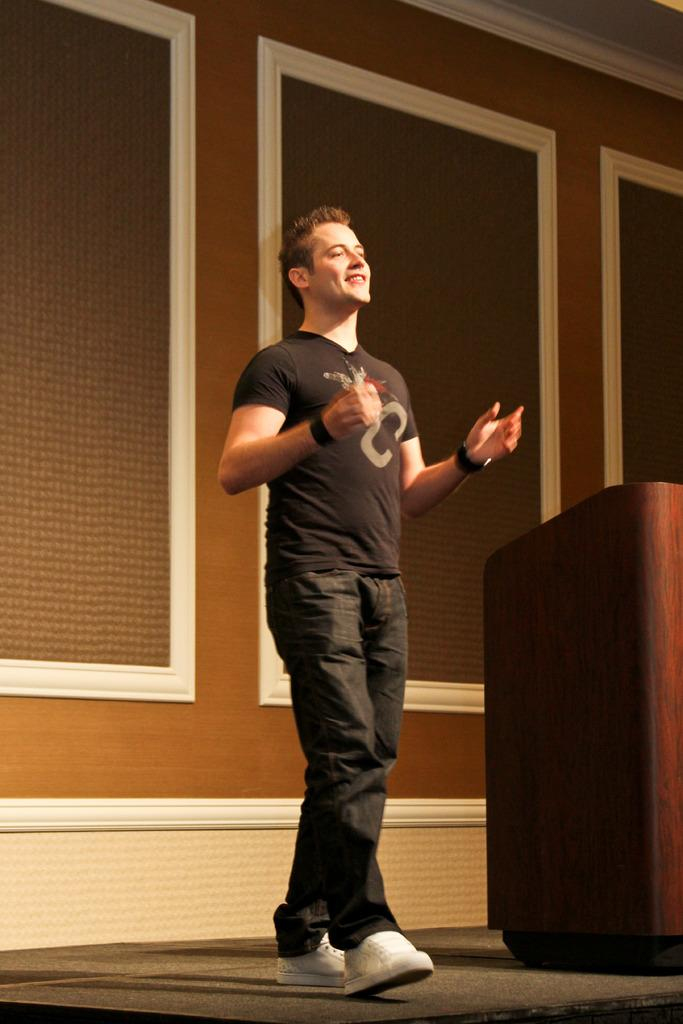Who is present in the image? There is a man in the image. What is the man doing in the image? The man is walking and smiling. What object can be seen in the image that is typically used for speeches or presentations? There is a podium in the image. What is visible in the background of the image? There is a wall in the background of the image. What type of ring can be seen on the man's finger in the image? There is no ring visible on the man's finger in the image. What type of club is the man holding in the image? There is no club present in the image; the man is simply walking and smiling. 